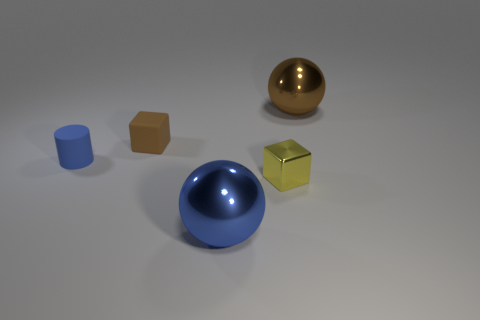What number of large yellow matte spheres are there?
Your response must be concise. 0. What number of balls are behind the blue thing to the right of the brown block?
Provide a short and direct response. 1. Does the metallic cube have the same color as the small rubber object that is in front of the small brown matte block?
Give a very brief answer. No. How many tiny purple shiny things have the same shape as the yellow metal thing?
Make the answer very short. 0. What material is the tiny block that is in front of the tiny brown object?
Give a very brief answer. Metal. There is a small rubber thing that is to the right of the tiny blue rubber cylinder; is its shape the same as the big blue object?
Provide a succinct answer. No. Are there any other cylinders that have the same size as the blue cylinder?
Provide a succinct answer. No. Does the small brown rubber object have the same shape as the small object that is right of the tiny brown rubber cube?
Give a very brief answer. Yes. What is the shape of the big thing that is the same color as the tiny cylinder?
Offer a terse response. Sphere. Is the number of blue rubber cylinders in front of the large blue object less than the number of tiny green cylinders?
Ensure brevity in your answer.  No. 